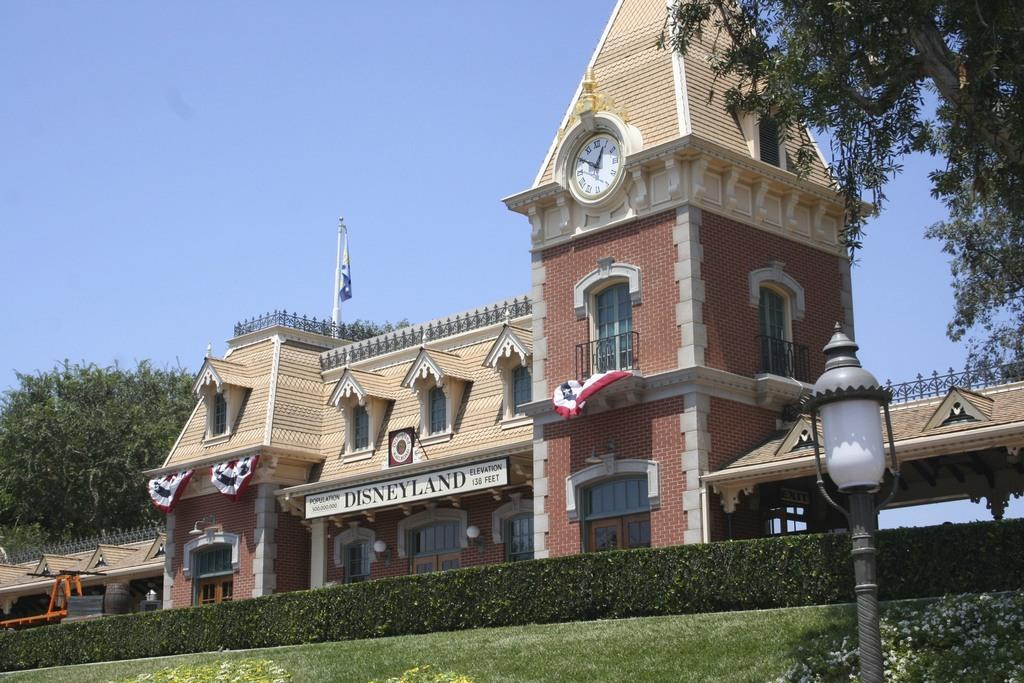<image>
Render a clear and concise summary of the photo. The building is the train station at the very exciting Disneyland! 